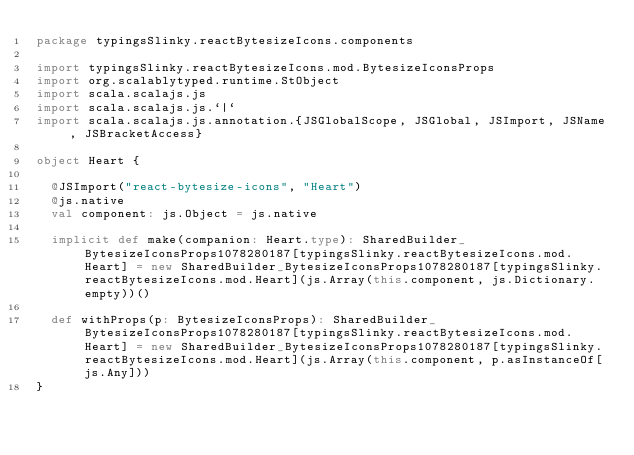Convert code to text. <code><loc_0><loc_0><loc_500><loc_500><_Scala_>package typingsSlinky.reactBytesizeIcons.components

import typingsSlinky.reactBytesizeIcons.mod.BytesizeIconsProps
import org.scalablytyped.runtime.StObject
import scala.scalajs.js
import scala.scalajs.js.`|`
import scala.scalajs.js.annotation.{JSGlobalScope, JSGlobal, JSImport, JSName, JSBracketAccess}

object Heart {
  
  @JSImport("react-bytesize-icons", "Heart")
  @js.native
  val component: js.Object = js.native
  
  implicit def make(companion: Heart.type): SharedBuilder_BytesizeIconsProps1078280187[typingsSlinky.reactBytesizeIcons.mod.Heart] = new SharedBuilder_BytesizeIconsProps1078280187[typingsSlinky.reactBytesizeIcons.mod.Heart](js.Array(this.component, js.Dictionary.empty))()
  
  def withProps(p: BytesizeIconsProps): SharedBuilder_BytesizeIconsProps1078280187[typingsSlinky.reactBytesizeIcons.mod.Heart] = new SharedBuilder_BytesizeIconsProps1078280187[typingsSlinky.reactBytesizeIcons.mod.Heart](js.Array(this.component, p.asInstanceOf[js.Any]))
}
</code> 